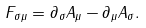Convert formula to latex. <formula><loc_0><loc_0><loc_500><loc_500>F _ { \sigma \mu } = \partial _ { \sigma } A _ { \mu } - \partial _ { \mu } A _ { \sigma } .</formula> 